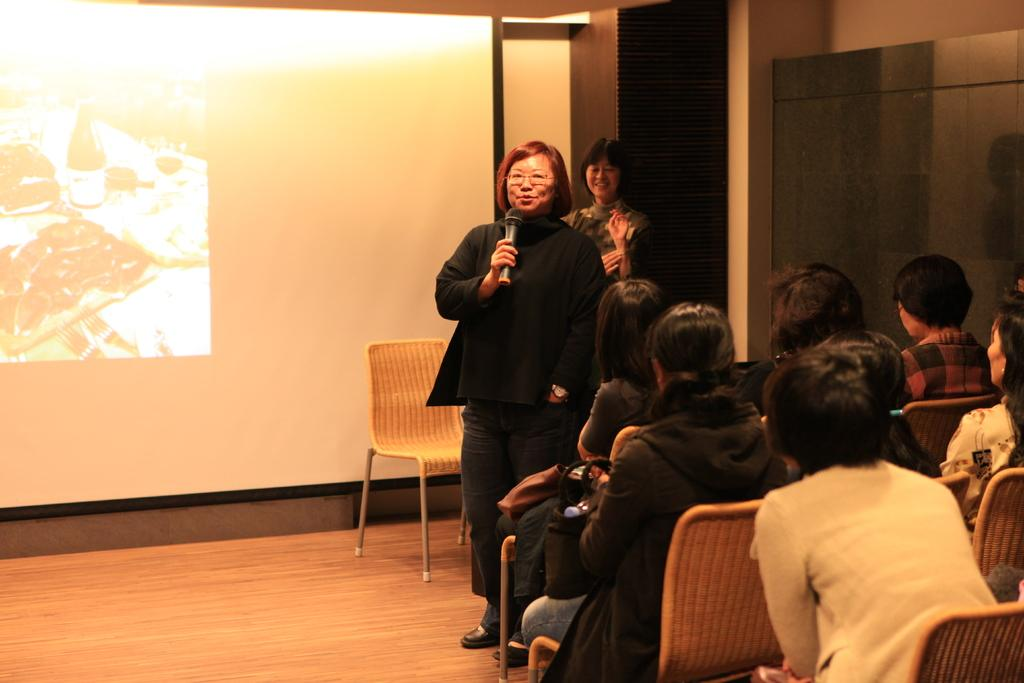What are the persons in the image doing? The persons in the image are sitting on chairs. Can you describe the woman in the image? The woman in the image is talking on a microphone. What is the surface visible in the image? The image shows a floor. What type of device is present in the image? There is a screen present in the image. What type of screw is being used to hold the hat in place in the image? There is no screw or hat present in the image. How many coils can be seen on the microphone in the image? The image does not show the microphone's internal components, so it is impossible to determine the number of coils. 